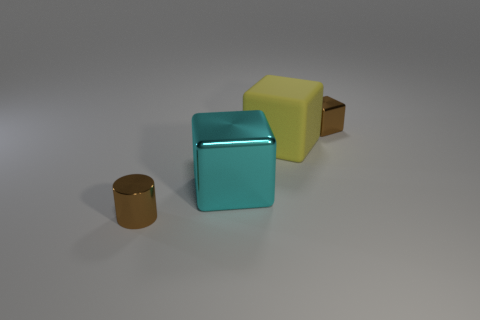There is a brown shiny cylinder; is it the same size as the shiny object that is behind the big yellow cube?
Your answer should be very brief. Yes. There is a tiny thing that is to the right of the small metallic object that is in front of the thing on the right side of the yellow matte block; what is its shape?
Your answer should be compact. Cube. Is the number of big blocks less than the number of yellow matte spheres?
Offer a very short reply. No. Are there any big cyan shiny cubes right of the yellow object?
Give a very brief answer. No. There is a thing that is to the left of the yellow object and behind the tiny metal cylinder; what is its shape?
Offer a very short reply. Cube. Are there any other small objects of the same shape as the matte thing?
Give a very brief answer. Yes. There is a brown block that is behind the brown metallic cylinder; is it the same size as the rubber block that is right of the tiny brown metal cylinder?
Provide a succinct answer. No. Is the number of small brown metallic cylinders greater than the number of tiny brown shiny objects?
Make the answer very short. No. How many small objects are the same material as the large cyan block?
Provide a short and direct response. 2. Is the cyan metal object the same shape as the large rubber object?
Make the answer very short. Yes. 